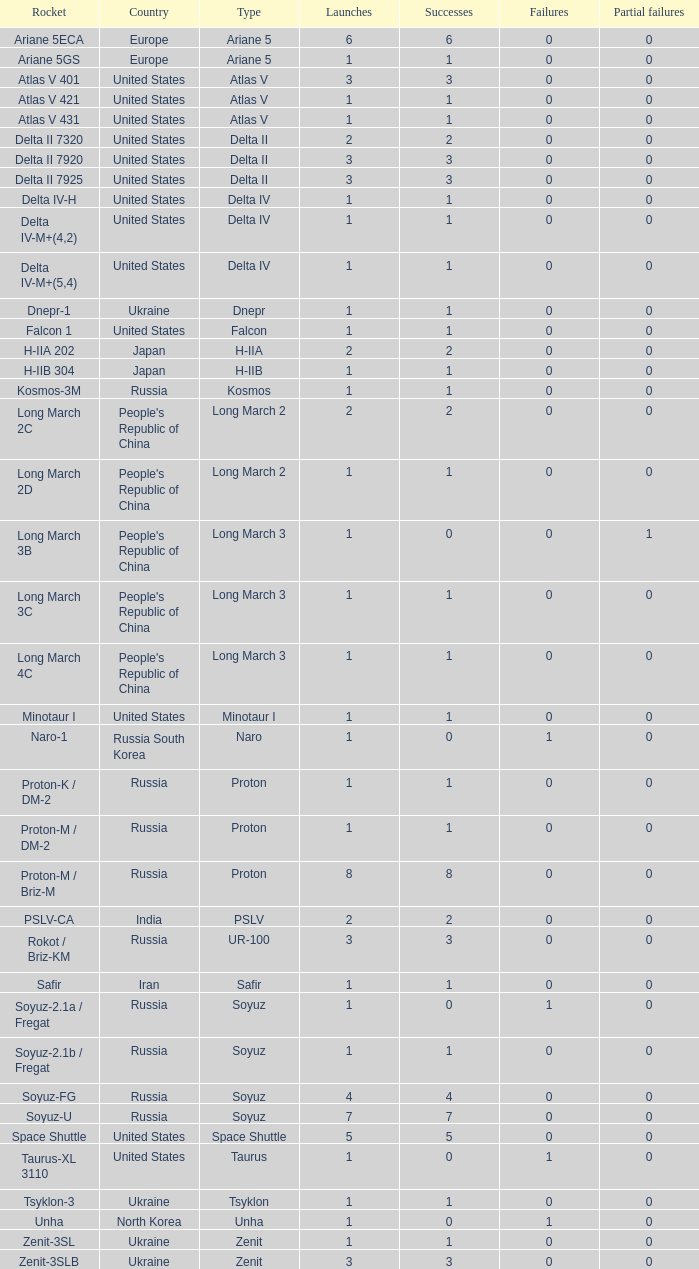What's the aggregate failures among rockets with more than 3 successes, categorized as ariane 5, and exceeding 0 partial failures? 0.0. 